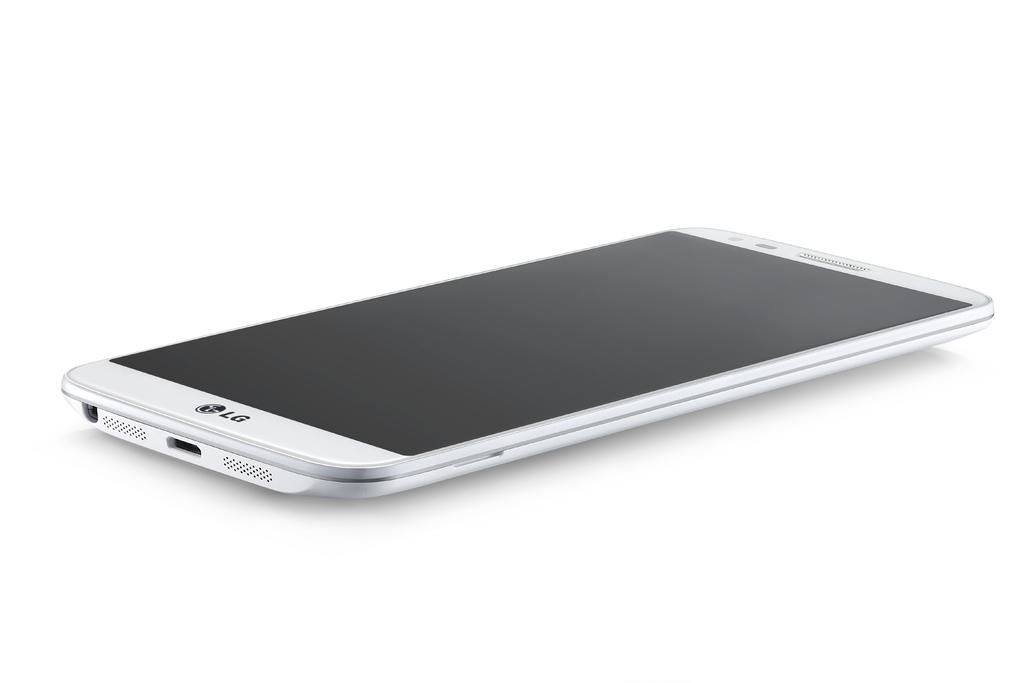Provide a one-sentence caption for the provided image. A slim, white LG cell phone laying right side up. 